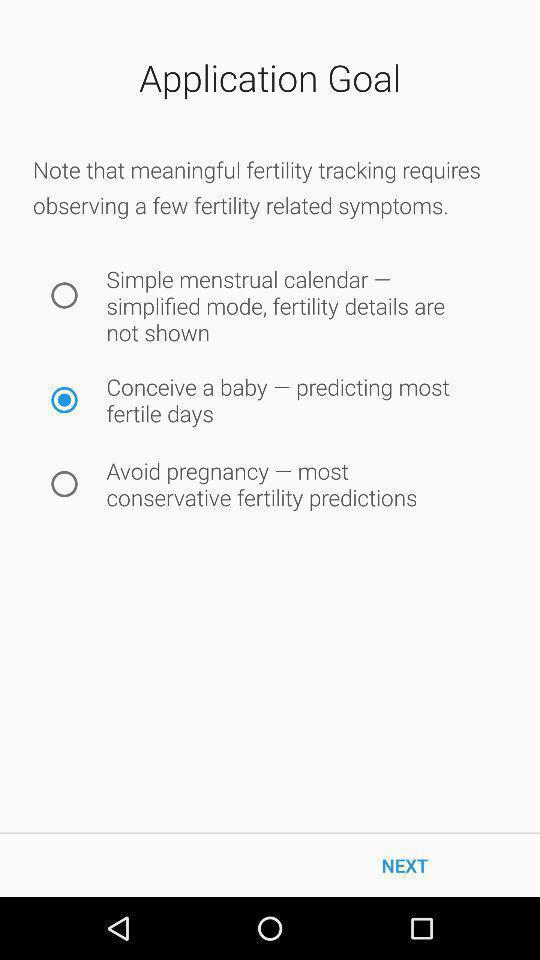Provide a detailed account of this screenshot. Page showing results of application goal in an health app. 